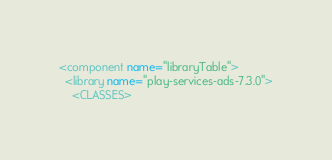<code> <loc_0><loc_0><loc_500><loc_500><_XML_><component name="libraryTable">
  <library name="play-services-ads-7.3.0">
    <CLASSES></code> 